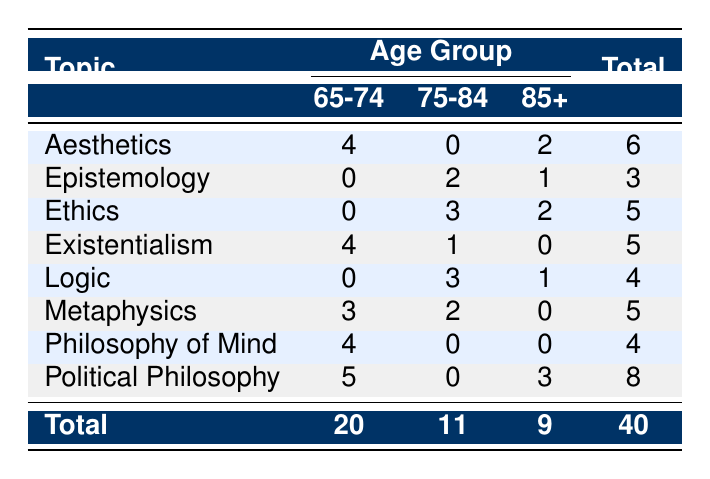What is the total number of philosophical discussions for clients aged 65-74? To find the total number of discussions for the age group 65-74, we need to look at the "Total" column corresponding to the "65-74" row. That value is 20.
Answer: 20 Which topic had the highest frequency among clients aged 75-84? We need to examine the frequencies for the age group 75-84 in the table and find the maximum value. The highest frequency for this age group is 5, which is for "Political Philosophy."
Answer: Political Philosophy Is there any topic for clients aged 85 and above that has a frequency greater than 2? By checking the frequencies for the age group 85+, we find that "Political Philosophy" has a frequency of 3 and "Ethics" has a frequency of 2. Since 3 is greater than 2, the answer is yes.
Answer: Yes What is the total frequency of discussions on "Logic" across all age groups? We find the frequency for "Logic" from each age group: 0 (65-74) + 3 (75-84) + 1 (85+) = 4. Summing these values gives us the total frequency of discussions on "Logic."
Answer: 4 How many more philosophical discussions were held on "Political Philosophy" than on "Aesthetics"? The frequency for "Political Philosophy" is 8 and for "Aesthetics," it is 6. Calculating the difference: 8 - 6 = 2. Thus, there were 2 more discussions on "Political Philosophy" than on "Aesthetics."
Answer: 2 What percentage of total discussions were held on "Ethics"? First, we need the total number of discussions, which is 40. The frequency of discussions on "Ethics" is 5. The percentage is then calculated as (5/40)*100 = 12.5%.
Answer: 12.5% Which age group discussed "Existentialism" the most? Looking at the frequencies for "Existentialism," we see 4 for 65-74, 1 for 75-84, and 0 for 85+. The highest frequency is 4 for the age group 65-74, indicating they discussed it the most.
Answer: 65-74 What is the average frequency of discussions across all topics for clients aged 85 and above? The frequency of discussions for clients aged 85+ is 3 (Political Philosophy) + 2 (Ethics) + 1 (Logic) = 6. There are 3 topics, so the average is 6/3 = 2.
Answer: 2 